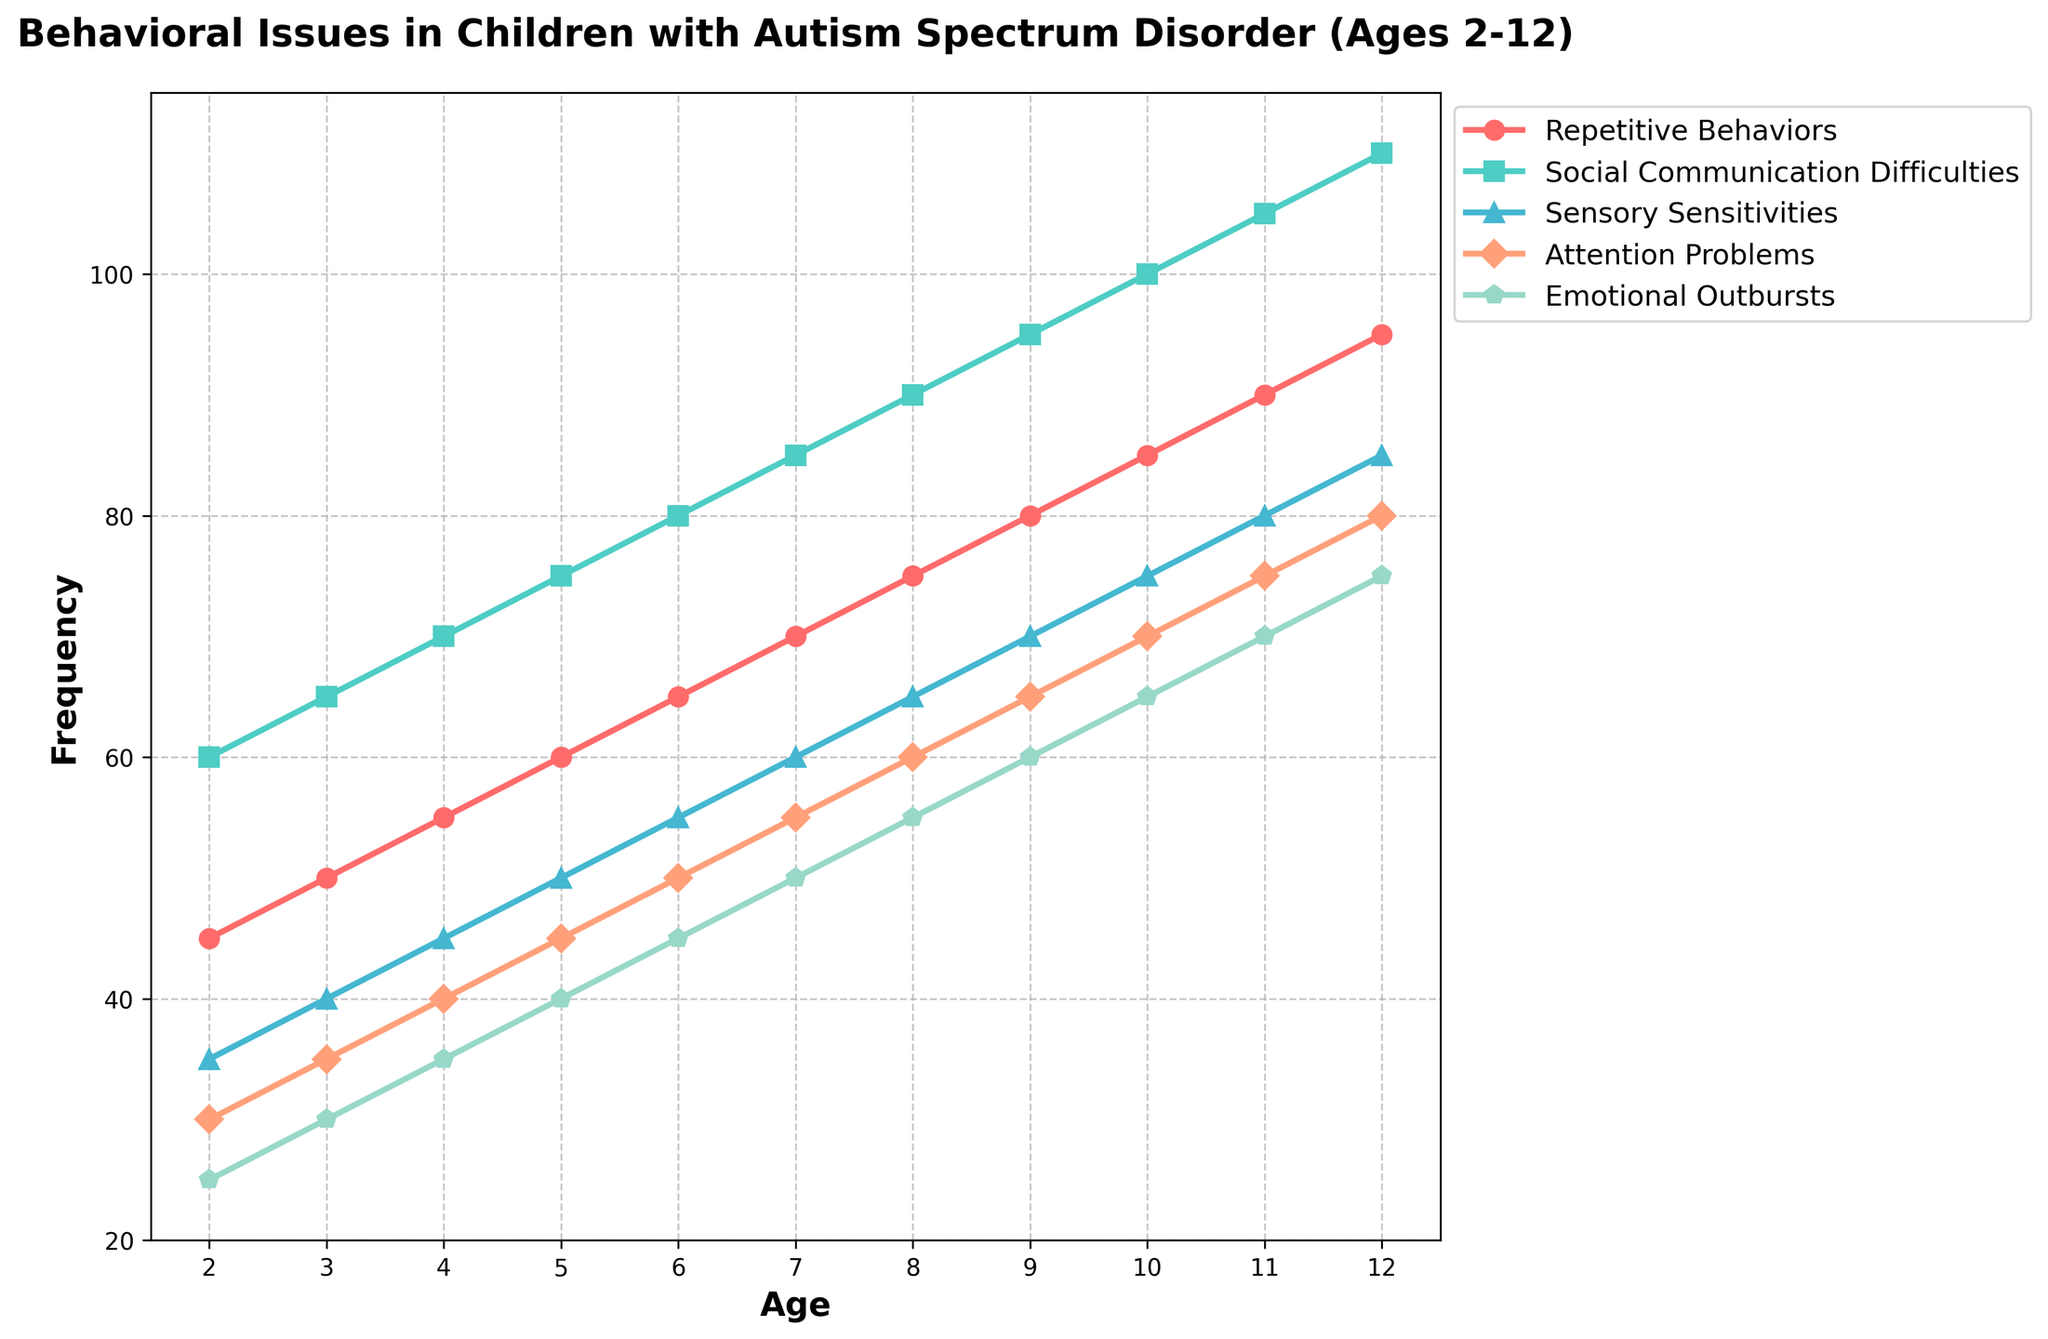What's the frequency of Repetitive Behaviors in children aged 6? Look at the line for Repetitive Behaviors and find the point corresponding to age 6. The frequency is 65.
Answer: 65 Which behavioral issue has the highest frequency at age 8? Check all the lines at age 8 and compare their frequencies. Social Communication Difficulties have the highest frequency, which is 90.
Answer: Social Communication Difficulties What is the difference in the frequency of Attention Problems between ages 2 and 12? Subtract the frequency at age 2 from the frequency at age 12 for Attention Problems. The difference is 80 - 30 = 50.
Answer: 50 By how much does the frequency of Emotional Outbursts increase from age 2 to age 11? Calculate the increase by subtracting the frequency at age 2 from the frequency at age 11 for Emotional Outbursts. The increase is 70 - 25 = 45.
Answer: 45 Which behavioral issue has the smallest increase in frequency from age 9 to age 12? Calculate the increase from age 9 to age 12 for each behavioral issue and find the smallest. Repetitive Behaviors: 95 - 80 = 15, Social Communication Difficulties: 110 - 95 = 15, Sensory Sensitivities: 85 - 70 = 15, Attention Problems: 80 - 65 = 15, Emotional Outbursts: 75 - 60 = 15. All issues increase by the same amount, 15.
Answer: All issues How many behavioral issues have a frequency greater than 70 at age 10? Count the number of lines above the frequency of 70 at age 10. Repetitive Behaviors (85), Social Communication Difficulties (100), Sensory Sensitivities (75), and Attention Problems (70). Four behavioral issues have a frequency greater than 70.
Answer: Four At what age do Attention Problems first reach a frequency of 50? Identify the age at which the line for Attention Problems first hits the frequency of 50, which is at age 6.
Answer: 6 What's the average frequency of Repetitive Behaviors over all ages? Sum the frequencies of Repetitive Behaviors at all ages and divide by the number of ages. The frequencies are 45, 50, 55, 60, 65, 70, 75, 80, 85, 90, 95. The sum is 770, and the average is 770/11 = 70.
Answer: 70 What is the range of frequencies for Sensory Sensitivities across all ages? Subtract the smallest frequency of Sensory Sensitivities (35 at age 2) from the largest (85 at age 12). The range is 85 - 35 = 50.
Answer: 50 How does the trend in frequency of Emotional Outbursts compare to that of Repetitive Behaviors from ages 3 to 7? Describe the slopes of the lines for Emotional Outbursts and Repetitive Behaviors between ages 3 and 7. Both lines show a steady increase, with Emotional Outbursts rising by 20 (50 - 30) and Repetitive Behaviors by 20 (70 - 50). The trends are similar.
Answer: Similar 